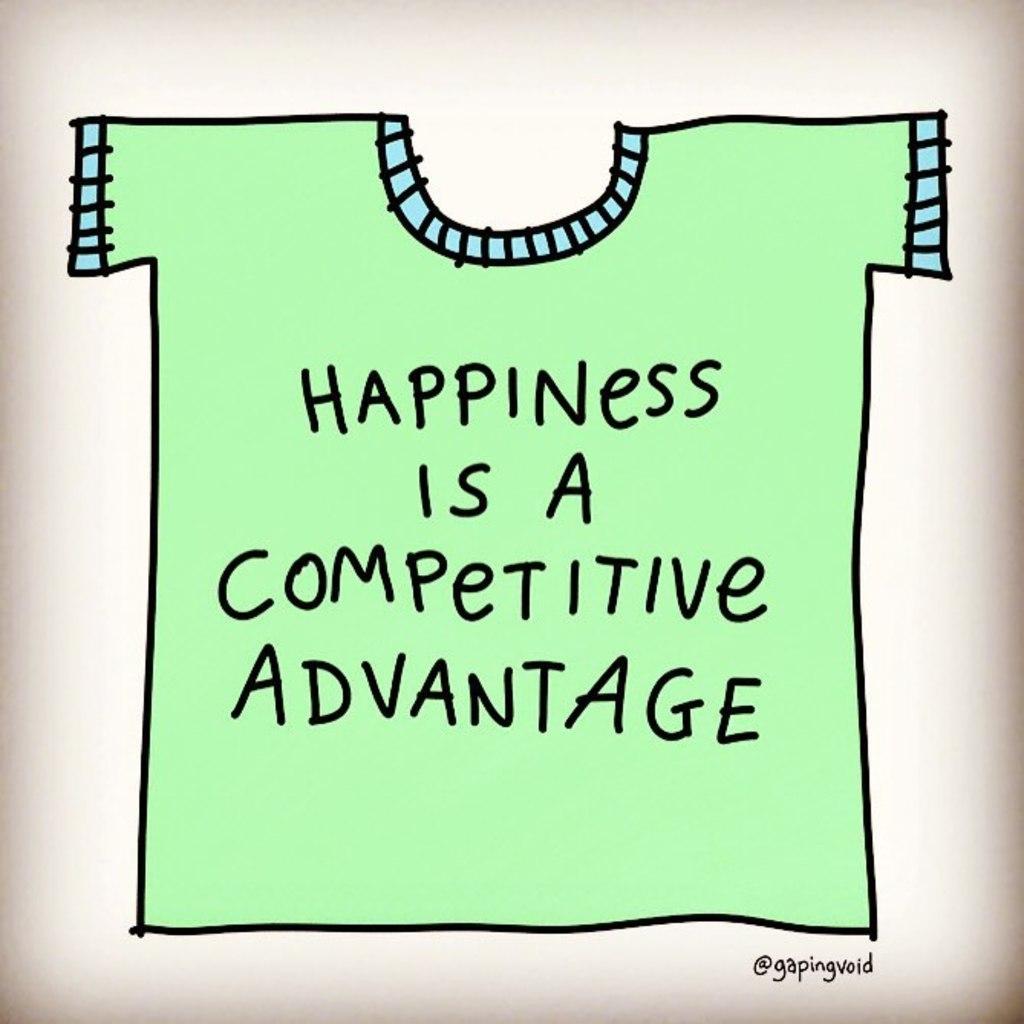In one or two sentences, can you explain what this image depicts? Here I can see a drawing of a t-shirt which is in green color. On this I can see some text in black color. 